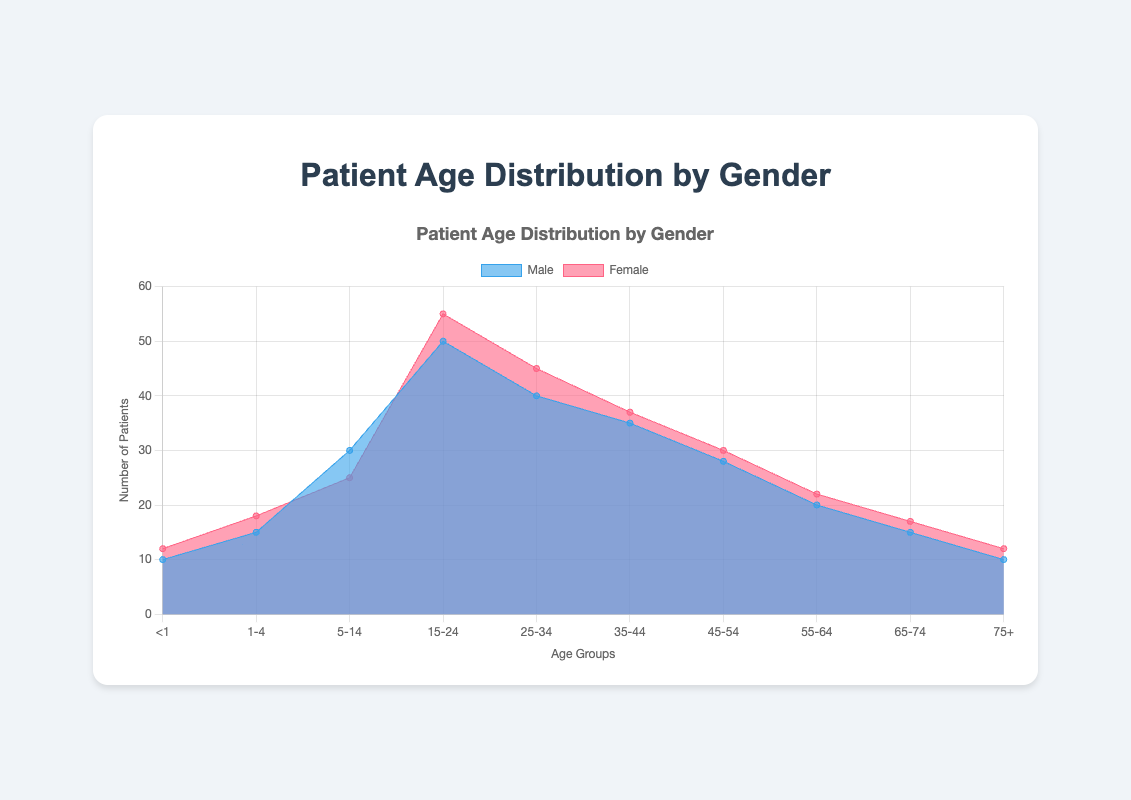What is the title of the chart? The title of the chart is displayed at the top and reads "Patient Age Distribution by Gender".
Answer: Patient Age Distribution by Gender How many age groups are represented in the chart? The x-axis shows a series of age ranges, specifically "<1", "1-4", "5-14", "15-24", "25-34", "35-44", "45-54", "55-64", "65-74", "75+". Counting these groups, we get a total of 10 distinct age groups.
Answer: 10 Which age group has the highest number of patients for females? Looking at the peak of the pink shaded area corresponding to females, the highest value occurs in the "15-24" age group.
Answer: 15-24 How do the numbers of male and female patients compare in the "5-14" age group? To compare, we look at the heights of the blue and pink areas for the "5-14" age group. The blue area (males) is at 30, and the pink area (females) is at 25. So, there are 5 more males than females in this age group.
Answer: 5 more males What is the difference in the number of patients between the 25-34 and 75+ age groups for males? For males, the number of patients in the "25-34" group is 40, while the number in the "75+" group is 10. The difference is calculated as 40 - 10 = 30.
Answer: 30 In which age group do males and females have the exact same number of patients? By comparing the heights of both areas for each age group, they match in the "<1" age group where both are at 10.
Answer: <1 What is the total number of patients in the "55-64" age group? Summing the patients for both genders in this age group: males have 20 and females have 22. Therefore, the total is 20 + 22 = 42.
Answer: 42 Which gender has a larger number of patients in the 45-54 age group? Observing the area heights in the 45-54 age group, males have 28 while females have 30. Thus, females have more patients.
Answer: Females What is the general trend in the number of patients as age increases for both genders? Generally, both genders show an increase in number of patients up to the 15-24 age group, after which the numbers tend to decrease as age increases.
Answer: Increases then decreases How does the total number of patients in the 1-4 age group compare to the total number in the 35-44 age group? Adding the male and female patients for each age group, we get: for "1-4", males are 15 and females are 18, totaling 33; for "35-44", males are 35 and females are 37, totaling 72. Thus, the 35-44 group has more patients.
Answer: 35-44 has more patients 